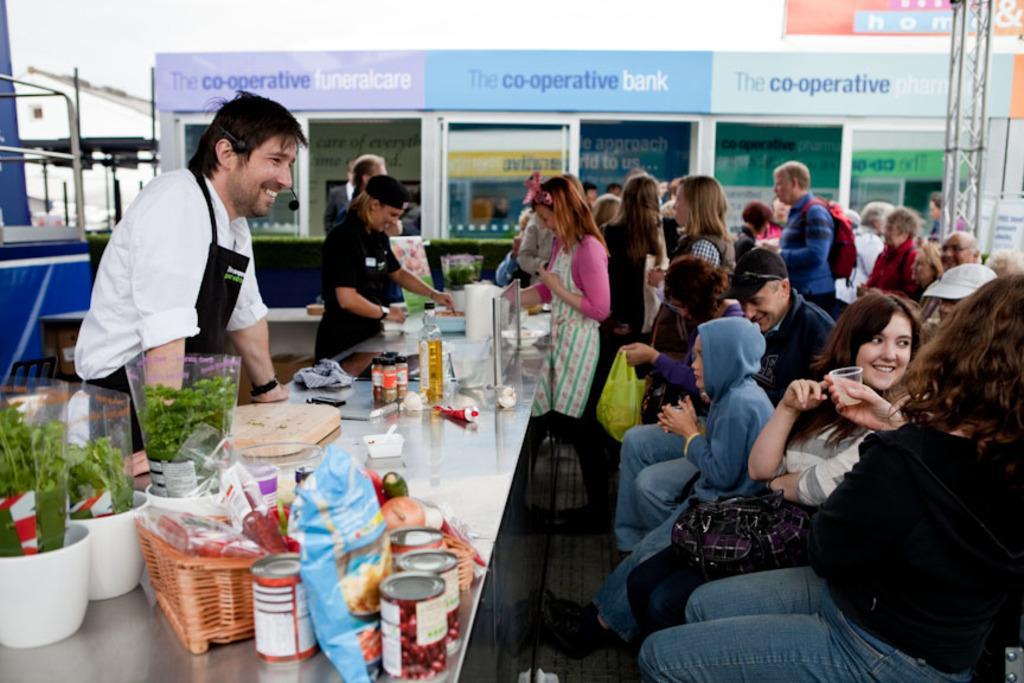How would you summarize this image in a sentence or two? This picture is taken outside. There are three people towards the left and group of people towards the right. In the center there is a table, on the table there are bowls, cans, bottles and some leafy vegetables. Towards the top right there is a tower, towards the bottom right there is a woman wearing a black t shirt and blue jeans. 